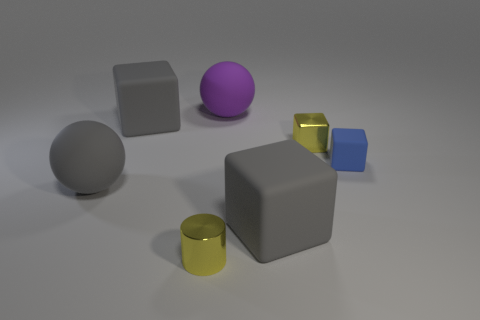Subtract all green blocks. Subtract all blue cylinders. How many blocks are left? 4 Add 1 yellow shiny cylinders. How many objects exist? 8 Subtract all cubes. How many objects are left? 3 Subtract all gray matte cubes. Subtract all yellow metal blocks. How many objects are left? 4 Add 5 tiny objects. How many tiny objects are left? 8 Add 1 large gray blocks. How many large gray blocks exist? 3 Subtract 0 red balls. How many objects are left? 7 